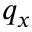<formula> <loc_0><loc_0><loc_500><loc_500>q _ { x }</formula> 